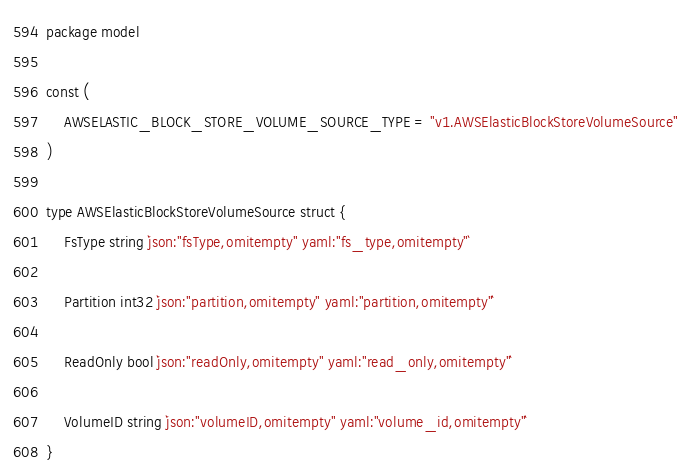Convert code to text. <code><loc_0><loc_0><loc_500><loc_500><_Go_>package model

const (
	AWSELASTIC_BLOCK_STORE_VOLUME_SOURCE_TYPE = "v1.AWSElasticBlockStoreVolumeSource"
)

type AWSElasticBlockStoreVolumeSource struct {
	FsType string `json:"fsType,omitempty" yaml:"fs_type,omitempty"`

	Partition int32 `json:"partition,omitempty" yaml:"partition,omitempty"`

	ReadOnly bool `json:"readOnly,omitempty" yaml:"read_only,omitempty"`

	VolumeID string `json:"volumeID,omitempty" yaml:"volume_id,omitempty"`
}
</code> 